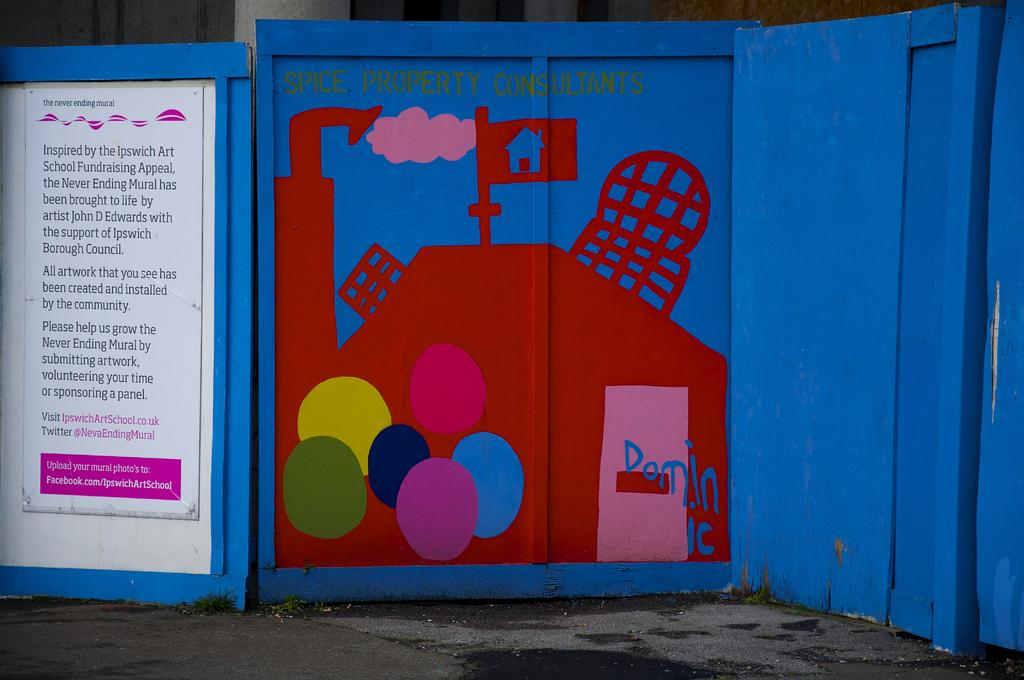<image>
Summarize the visual content of the image. someone has tagged dominic on a wall with red and blue paint 